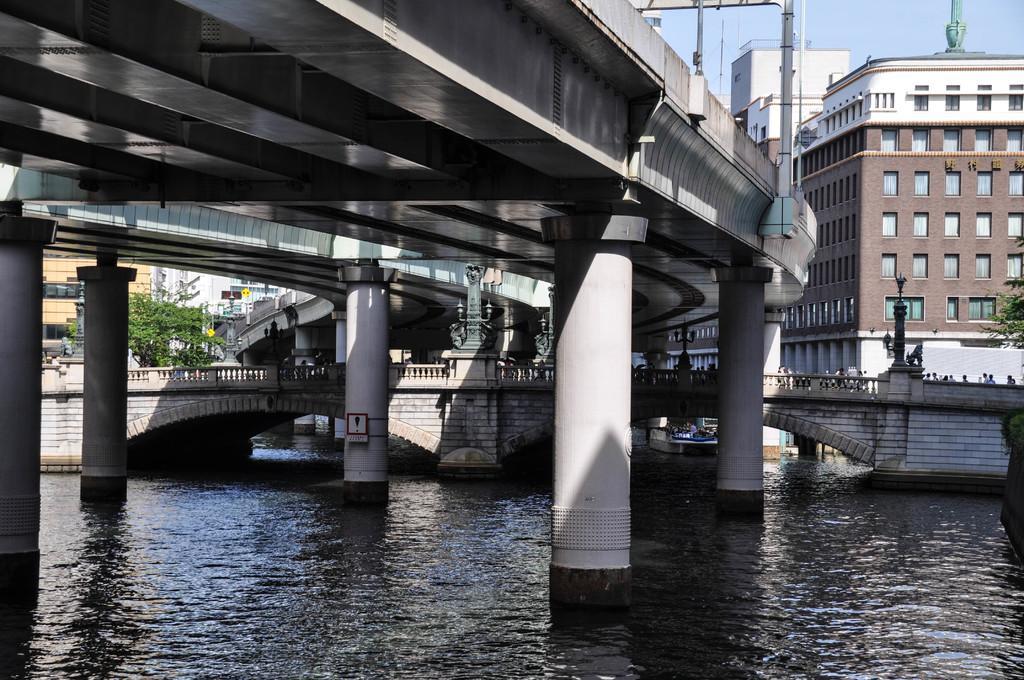Please provide a concise description of this image. In this image there is water at the bottom. There is a bridge above it. Above the bridge there is another bridge. On the right side there is a building in the background. On the left side there are trees beside the bridge. There are few people walking on the bridge. At the top there is the sky. There are poles which are attached to the wall of the bridge. 